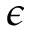<formula> <loc_0><loc_0><loc_500><loc_500>\epsilon</formula> 